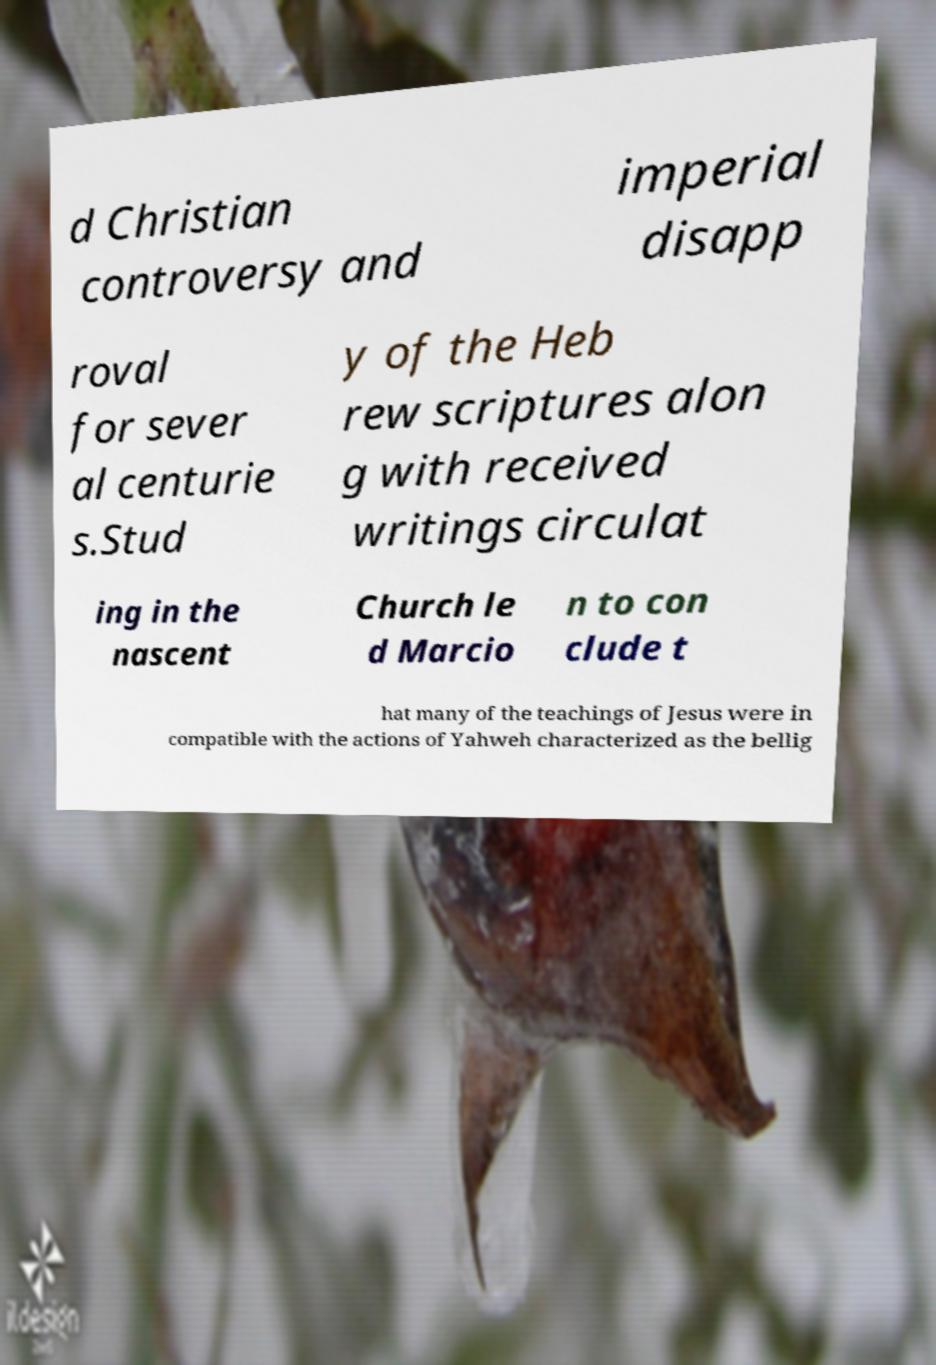Please identify and transcribe the text found in this image. d Christian controversy and imperial disapp roval for sever al centurie s.Stud y of the Heb rew scriptures alon g with received writings circulat ing in the nascent Church le d Marcio n to con clude t hat many of the teachings of Jesus were in compatible with the actions of Yahweh characterized as the bellig 